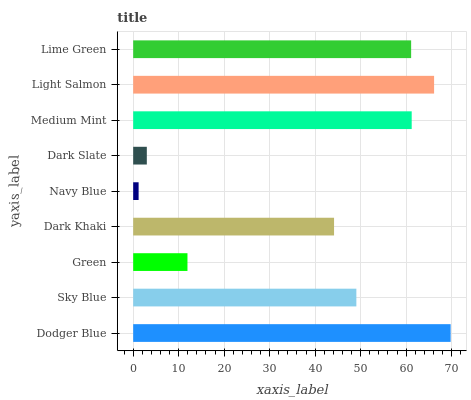Is Navy Blue the minimum?
Answer yes or no. Yes. Is Dodger Blue the maximum?
Answer yes or no. Yes. Is Sky Blue the minimum?
Answer yes or no. No. Is Sky Blue the maximum?
Answer yes or no. No. Is Dodger Blue greater than Sky Blue?
Answer yes or no. Yes. Is Sky Blue less than Dodger Blue?
Answer yes or no. Yes. Is Sky Blue greater than Dodger Blue?
Answer yes or no. No. Is Dodger Blue less than Sky Blue?
Answer yes or no. No. Is Sky Blue the high median?
Answer yes or no. Yes. Is Sky Blue the low median?
Answer yes or no. Yes. Is Dodger Blue the high median?
Answer yes or no. No. Is Dark Khaki the low median?
Answer yes or no. No. 